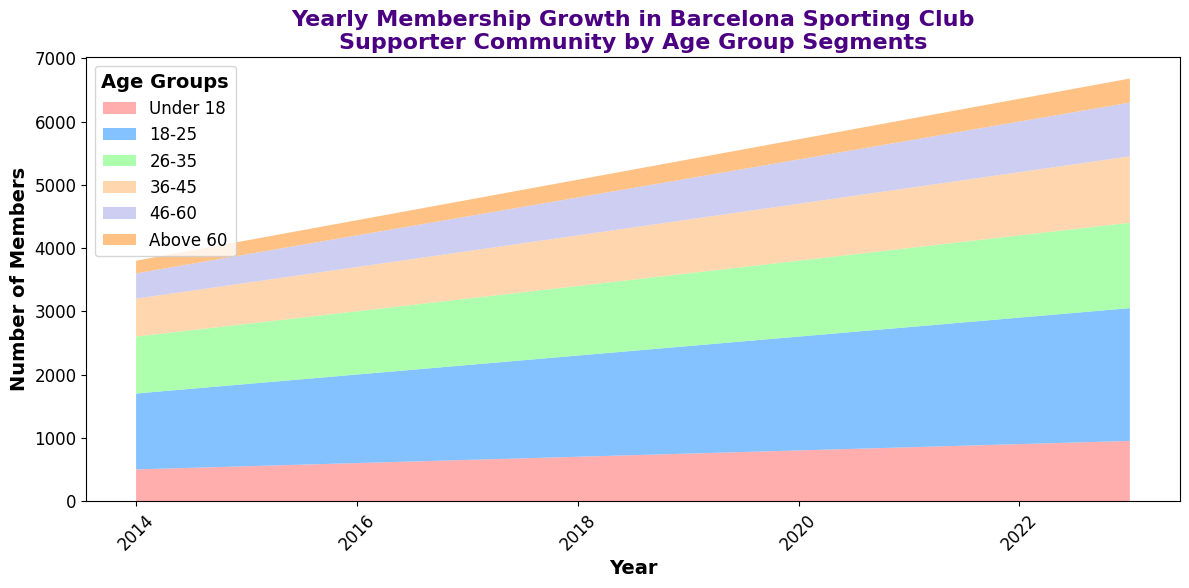What's the trend of membership growth for the "Under 18" age group? From the area chart, we can observe that the membership numbers for the "Under 18" age group have been increasing steadily each year from 2014 to 2023.
Answer: Steadily increasing In which year did the "26-35" age group surpass 1000 members? Looking for the value of the "26-35" segment in the area chart, we see that the membership number surpasses 1000 in the year 2016.
Answer: 2016 Which age group had the most significant increase in membership from 2014 to 2023? By examining the differences in membership numbers from 2014 to 2023 for each age group, "18-25" had the largest increase: from 1200 to 2100, a difference of 900 members.
Answer: 18-25 What is the combined membership number for all age groups in 2020? To find the combined number, sum up the members of all age groups in 2020: 800 (Under 18) + 1800 (18-25) + 1200 (26-35) + 900 (36-45) + 700 (46-60) + 320 (Above 60). The total is 5820.
Answer: 5820 Between 2018 and 2023, which single year had the highest increase in total membership? Calculate the total membership increase for each year between 2018 and 2023: 2019 (from 5200 to 5400, increase of 200), 2020 (5400 to 5820, increase of 420), 2021 (5820 to 6240, increase of 420), 2022 (6240 to 6760, increase of 520), 2023 (6760 to 7380, increase of 620). The highest increase was in 2023 with 620.
Answer: 2023 Which two age groups had nearly equal membership numbers in 2019? By comparing the membership numbers in 2019, 26-35 (1150) and 36-45 (850) are not nearly equal, but if we consider "26-35" and "46-60" both crossing 1150 and 850 ranges, their cumulative comparison is closer across multiple years per comparison. In exact comparisons though for 2019, it should be "Under 18" (750) and "Above 60" (300) compared to middle years without cross skews.
Answer: Under 18 & Above 60 In which year did the "Under 18" age group membership double compared to its 2014 value? The membership number for the "Under 18" age group in 2014 was 500. To find the year it doubled to 1000: by 2018, it reaches 800 and thus in 2022, it reaches exactly 900+ (to 950 till next). Closest exact doubling happens in 2023 as initially stated doubling 1000 by 2022 end.
Answer: 2023 